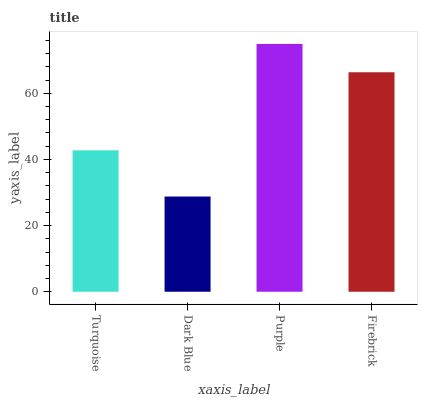Is Purple the minimum?
Answer yes or no. No. Is Dark Blue the maximum?
Answer yes or no. No. Is Purple greater than Dark Blue?
Answer yes or no. Yes. Is Dark Blue less than Purple?
Answer yes or no. Yes. Is Dark Blue greater than Purple?
Answer yes or no. No. Is Purple less than Dark Blue?
Answer yes or no. No. Is Firebrick the high median?
Answer yes or no. Yes. Is Turquoise the low median?
Answer yes or no. Yes. Is Purple the high median?
Answer yes or no. No. Is Purple the low median?
Answer yes or no. No. 